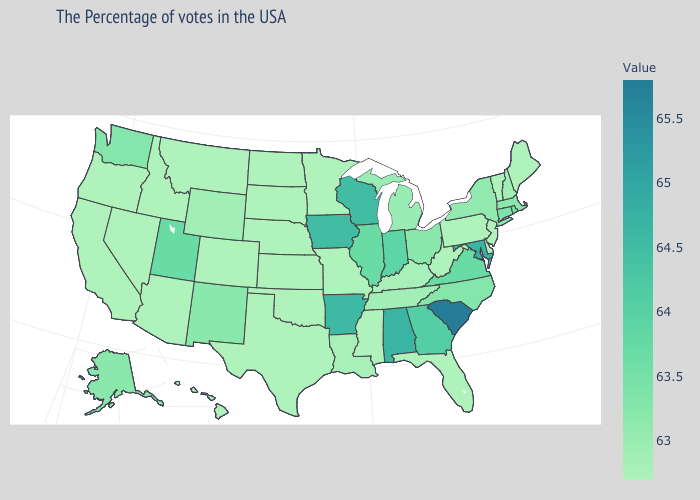Which states have the highest value in the USA?
Quick response, please. South Carolina. Does Kansas have the lowest value in the USA?
Short answer required. Yes. Among the states that border Georgia , which have the highest value?
Write a very short answer. South Carolina. Does Alabama have the highest value in the USA?
Be succinct. No. Among the states that border Missouri , which have the lowest value?
Give a very brief answer. Kansas, Nebraska, Oklahoma. Does Utah have the lowest value in the USA?
Be succinct. No. Does the map have missing data?
Keep it brief. No. 